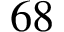<formula> <loc_0><loc_0><loc_500><loc_500>6 8</formula> 